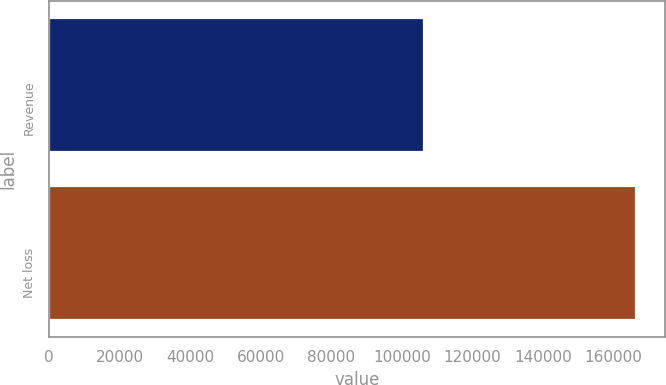Convert chart to OTSL. <chart><loc_0><loc_0><loc_500><loc_500><bar_chart><fcel>Revenue<fcel>Net loss<nl><fcel>106313<fcel>166317<nl></chart> 